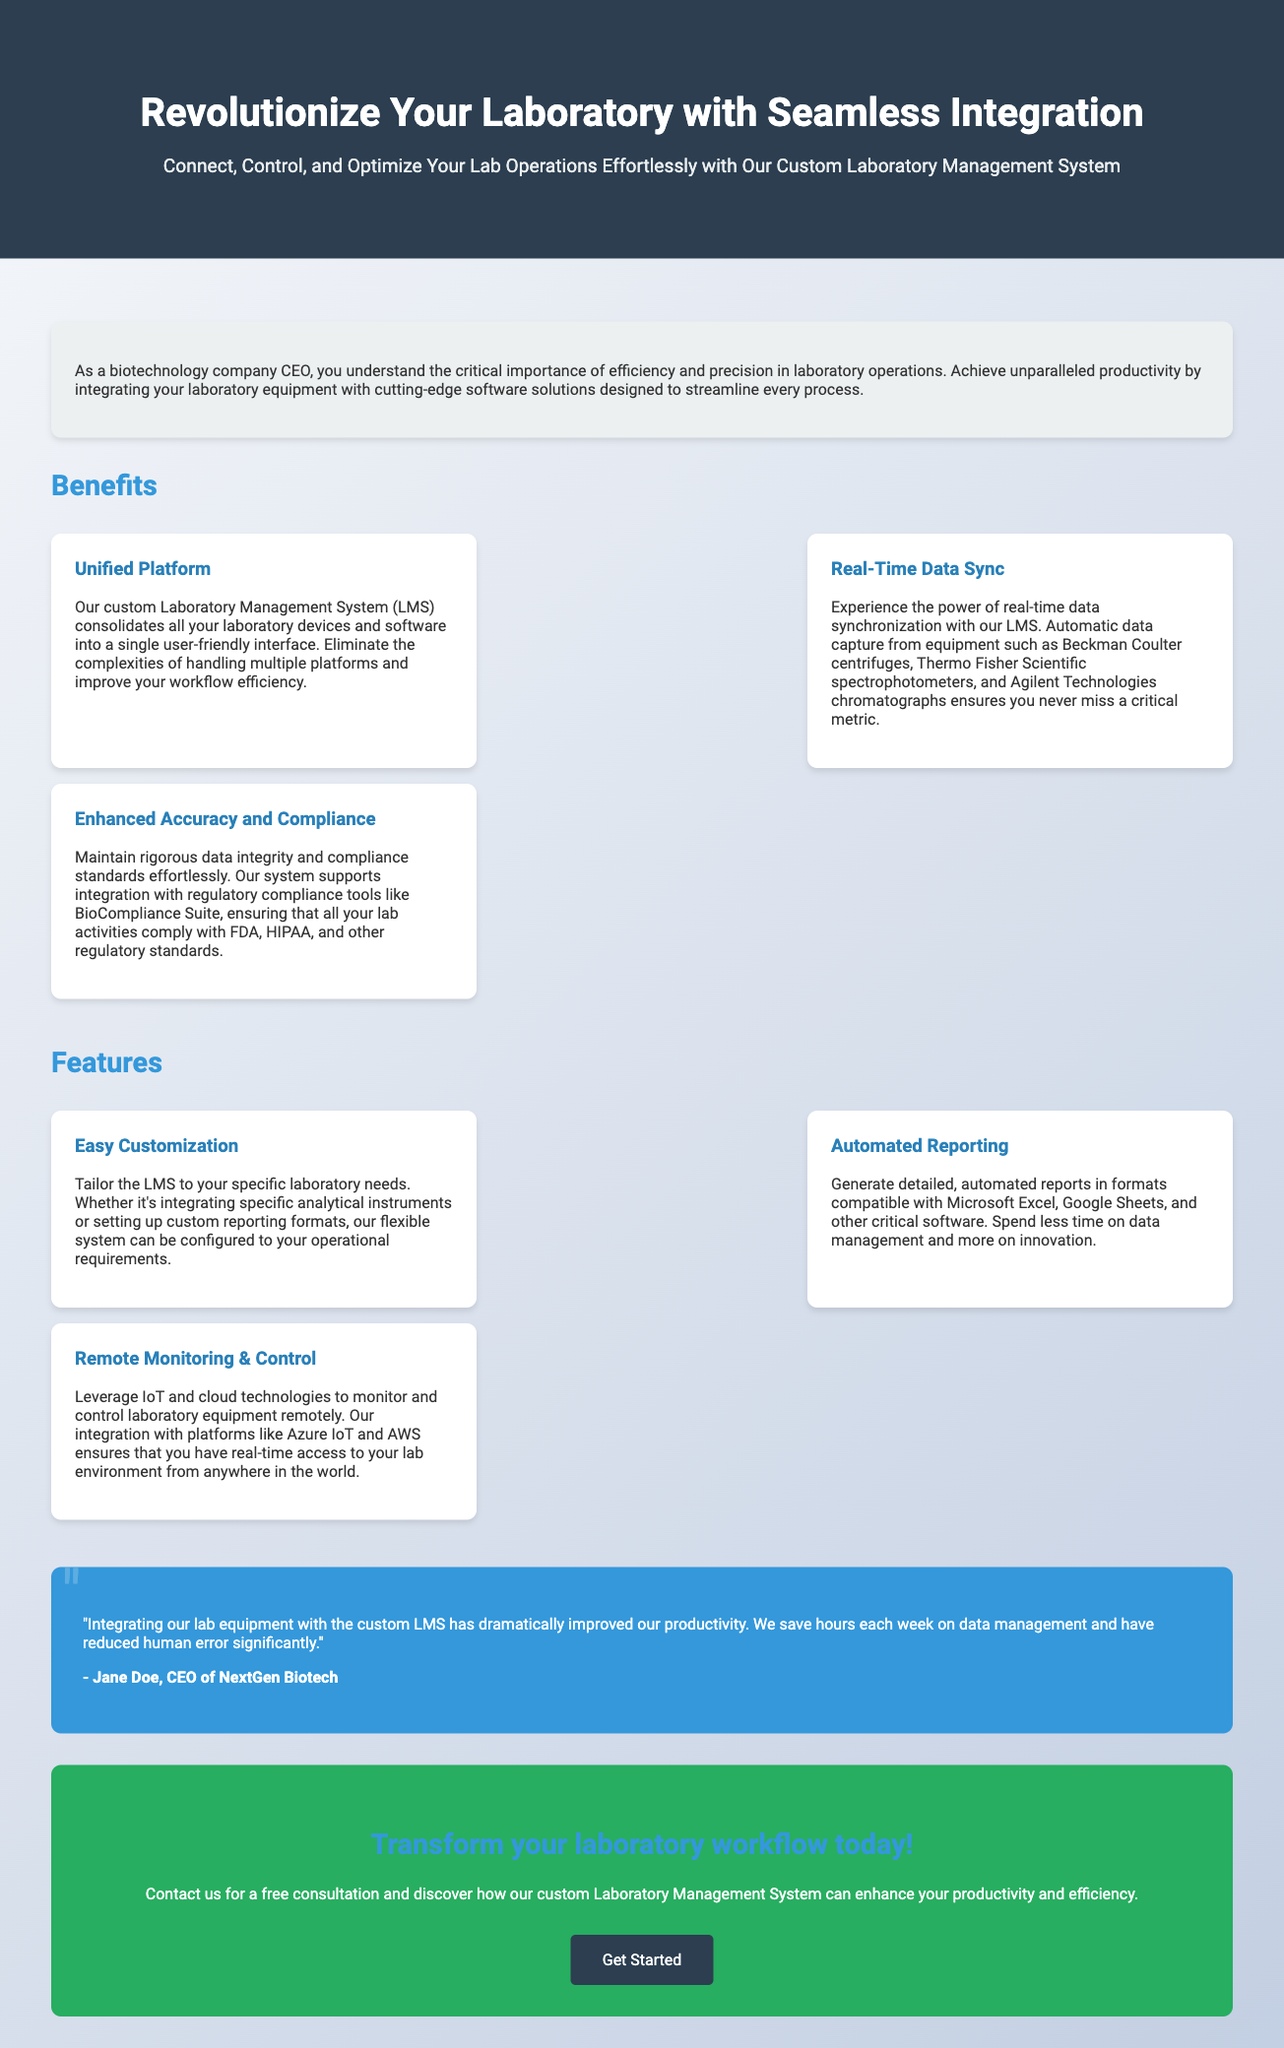What is the title of the advertisement? The title is prominently displayed at the top of the document, focusing on the central theme.
Answer: Revolutionize Your Laboratory with Seamless Integration Who is the target audience of this advertisement? The introduction specifies the intended audience for the advertisement.
Answer: biotechnology company CEO What benefits include real-time data sync? The benefits section highlights specific advantages of using the LMS.
Answer: automatic data capture from equipment Which compliance standards does the system support? The benefits section details specific regulatory standards that the system adheres to.
Answer: FDA, HIPAA What feature allows customization according to laboratory needs? The features section describes ways the LMS can be tailored to specific requirements.
Answer: Easy Customization What technological integration is mentioned for remote access? The features section specifies technology used to enable remote monitoring and control.
Answer: Azure IoT and AWS What is the main call to action in the advertisement? The conclusion of the advertisement urges readers towards a specific action.
Answer: Transform your laboratory workflow today Who provided a testimonial in the advertisement? The testimonial section identifies the person who shares their positive experience.
Answer: Jane Doe, CEO of NextGen Biotech How much time does the integration save each week? The testimonial mentions a specific advantage in terms of time savings.
Answer: hours each week on data management 